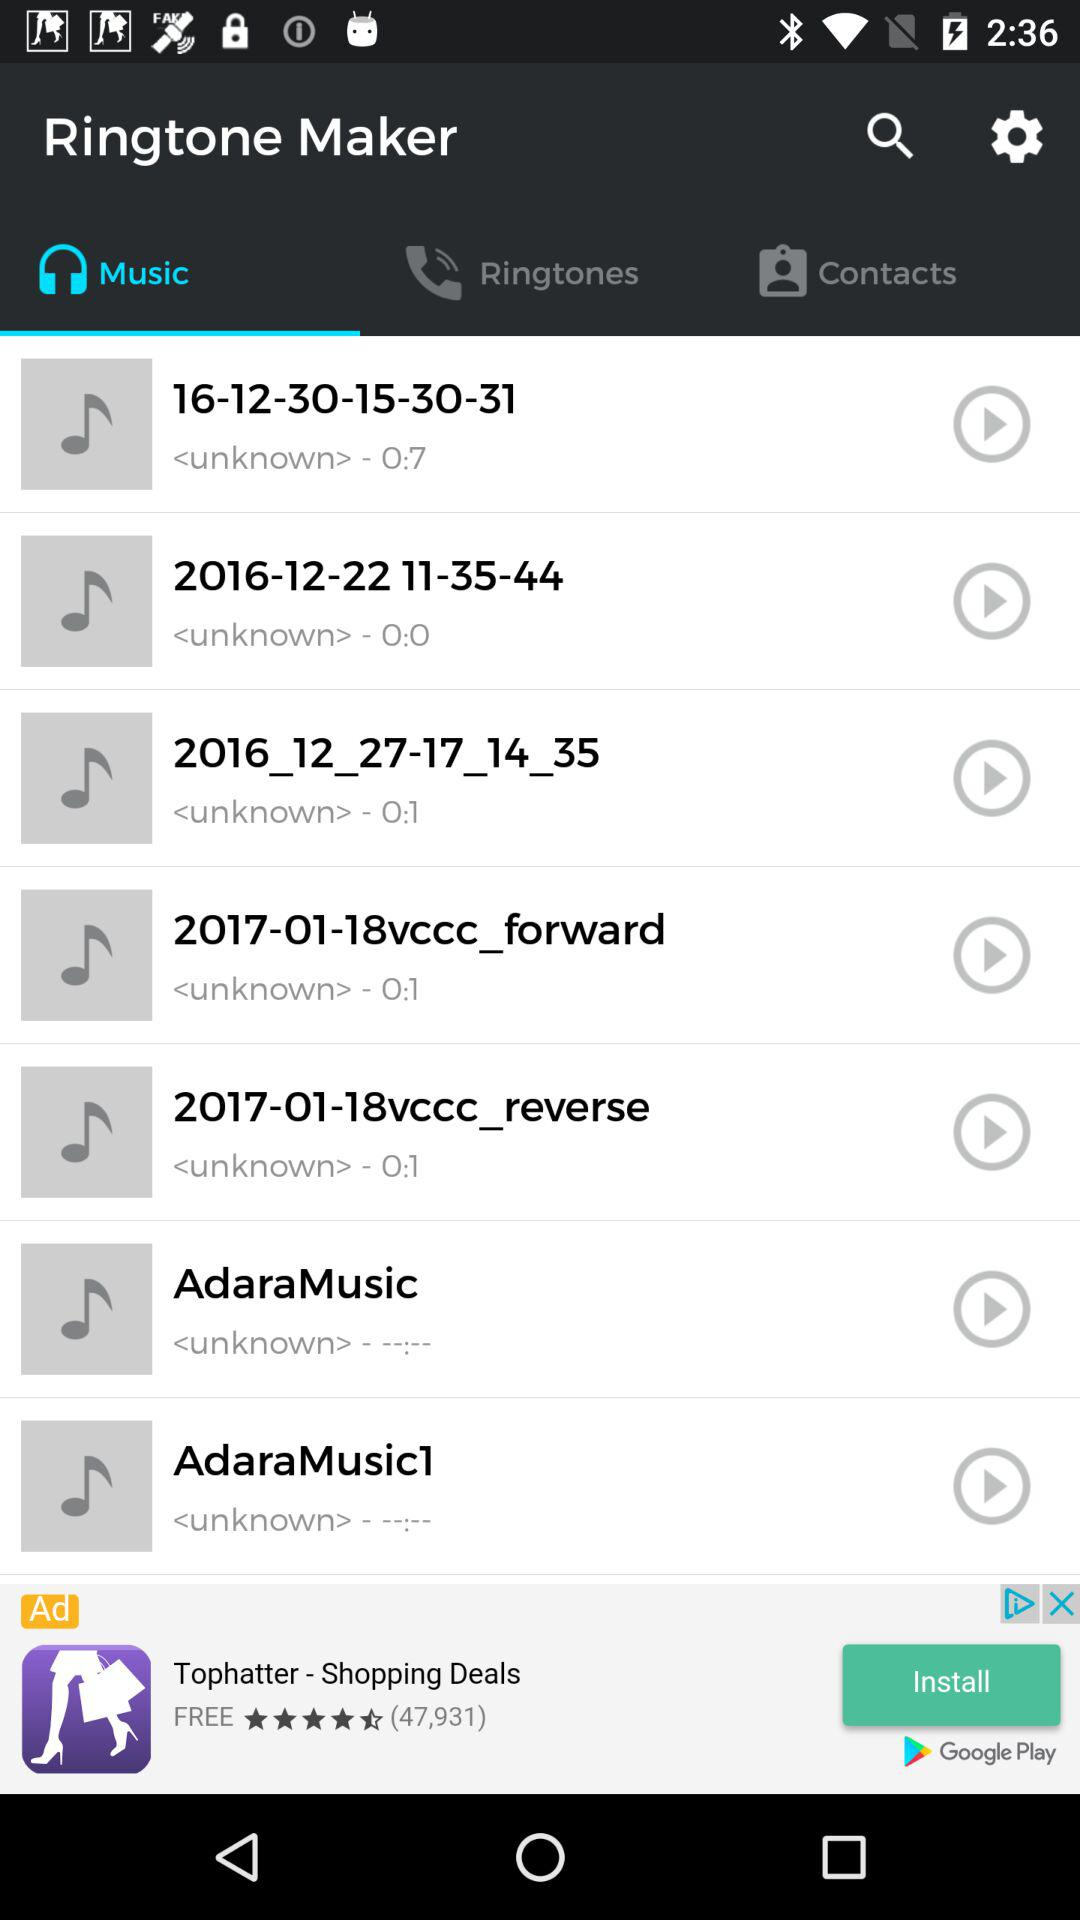What is the time duration of the 16-12-30-15-30-31? The time duration is 7 seconds. 